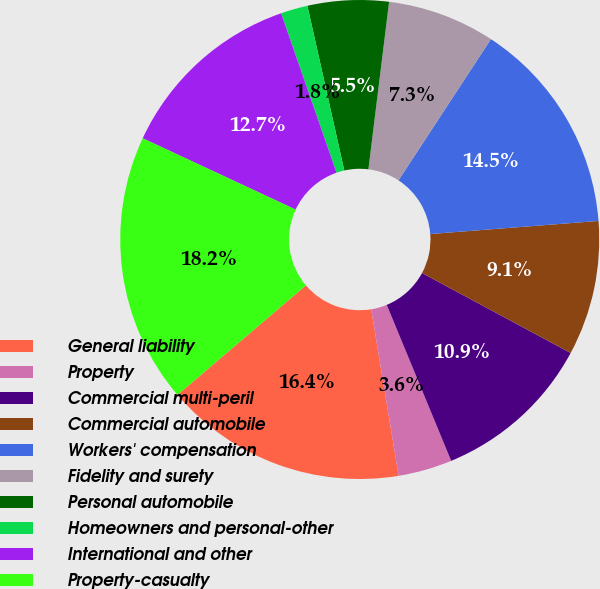Convert chart. <chart><loc_0><loc_0><loc_500><loc_500><pie_chart><fcel>General liability<fcel>Property<fcel>Commercial multi-peril<fcel>Commercial automobile<fcel>Workers' compensation<fcel>Fidelity and surety<fcel>Personal automobile<fcel>Homeowners and personal-other<fcel>International and other<fcel>Property-casualty<nl><fcel>16.36%<fcel>3.64%<fcel>10.91%<fcel>9.09%<fcel>14.54%<fcel>7.27%<fcel>5.46%<fcel>1.82%<fcel>12.73%<fcel>18.18%<nl></chart> 